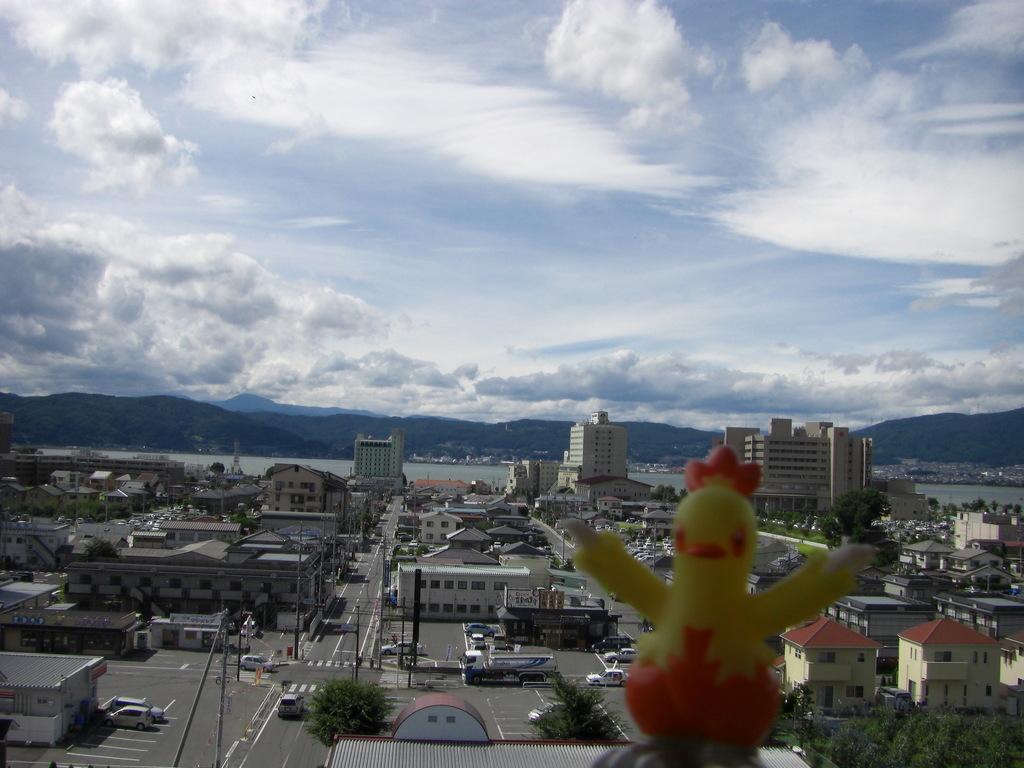Please provide a concise description of this image. This picture is clicked outside. On the right we can see the toy and in the background we can see the sky with the clouds and we can see the buildings, houses, vehicles, metal rods and trees and many other objects. 